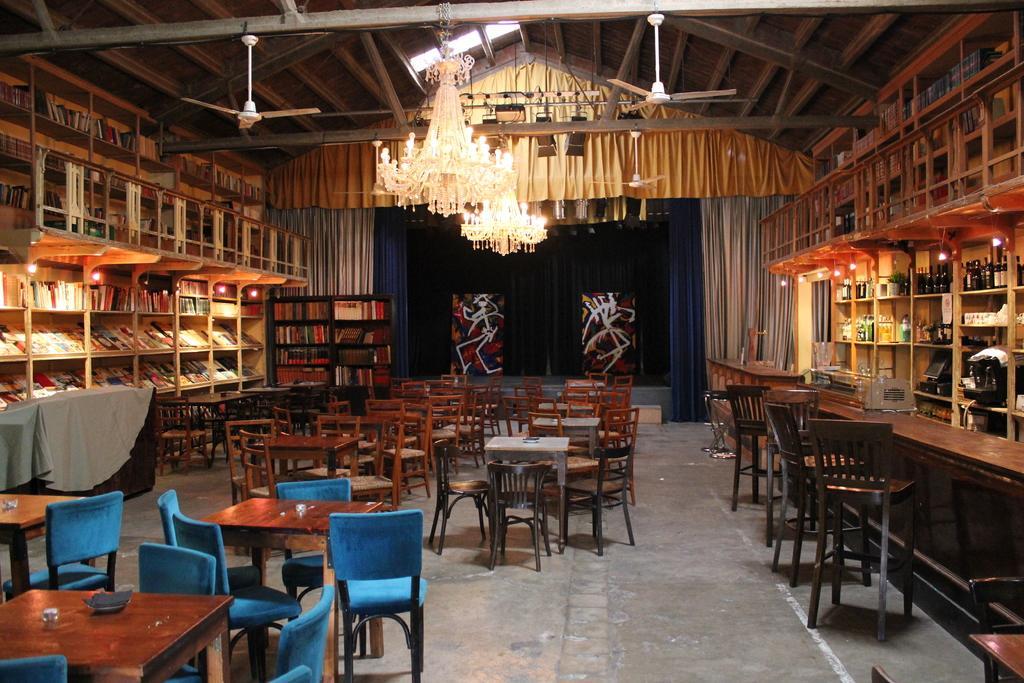Describe this image in one or two sentences. In this image I can see a room which has many tables and chairs. There are bookshelves on the left. There are glass bottles on the right. There are chandeliers and fans on the top and curtains at the back. 